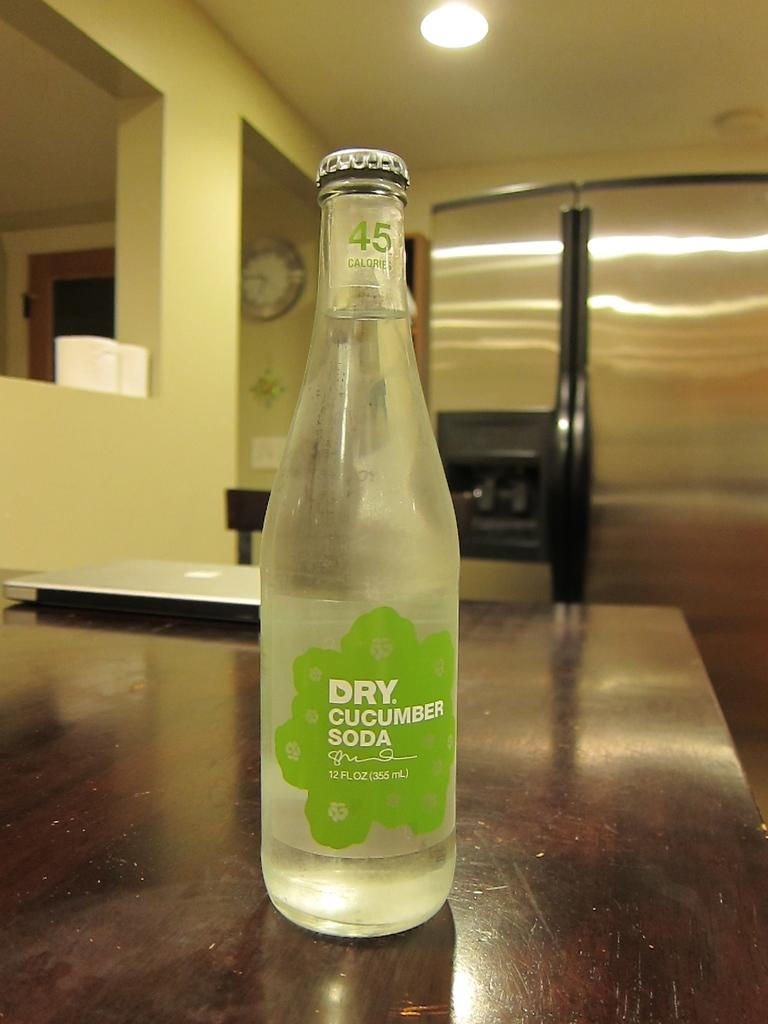What object can be seen in the image? There is a bottle in the image. Where is the bottle located? The bottle is on a table. What color is the label on the bottle? The label on the bottle is green. What else is on the table besides the bottle? There is a system on the table. Can you hear the bottle crying in the image? There is no sound or emotion associated with the bottle in the image, so it cannot be heard crying. 